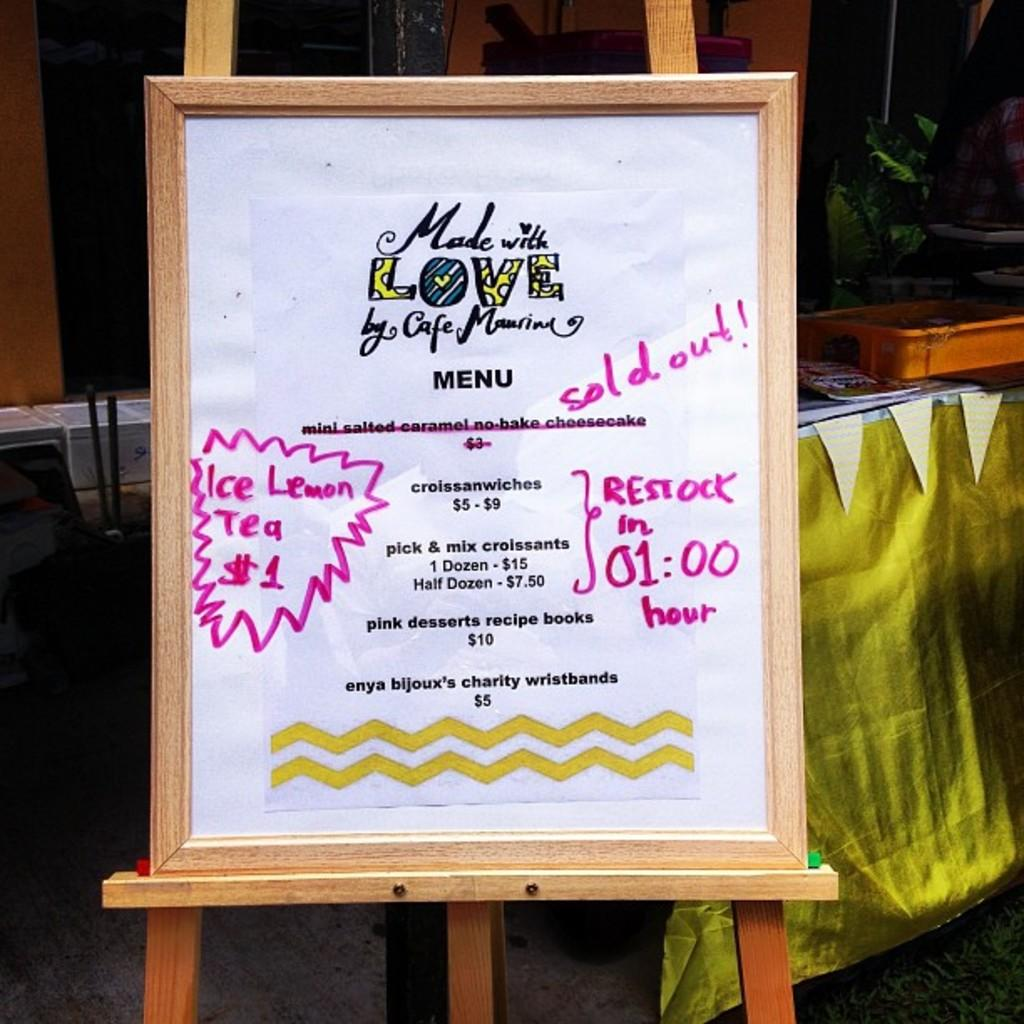What object in the image has a photo frame? There is a photo frame in the image, but the specific object it is attached to is not mentioned. What is written on the photo frame? There is writing on the photo frame. What piece of furniture is present in the image? There is a table in the image. What type of container is visible in the image? There is a container in the image. What is placed on top of the container? There are objects on the container. What type of window treatment is present in the image? There is a curtain in the image. Can you see any pear-shaped objects in the image? There is no mention of a pear or any pear-shaped objects in the image. What type of power source is visible in the image? There is no mention of a power source or any electrical components in the image. 